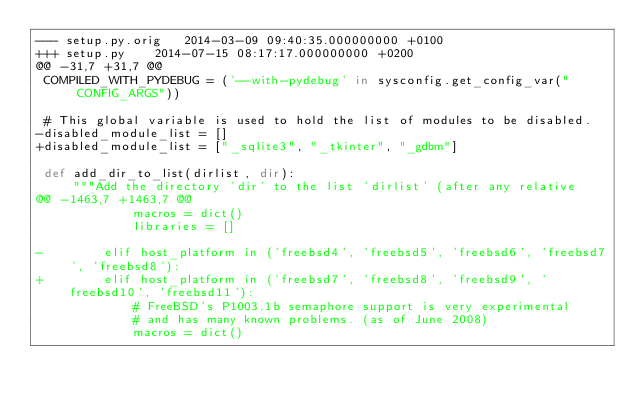<code> <loc_0><loc_0><loc_500><loc_500><_Python_>--- setup.py.orig	2014-03-09 09:40:35.000000000 +0100
+++ setup.py	2014-07-15 08:17:17.000000000 +0200
@@ -31,7 +31,7 @@
 COMPILED_WITH_PYDEBUG = ('--with-pydebug' in sysconfig.get_config_var("CONFIG_ARGS"))
 
 # This global variable is used to hold the list of modules to be disabled.
-disabled_module_list = []
+disabled_module_list = ["_sqlite3", "_tkinter", "_gdbm"]
 
 def add_dir_to_list(dirlist, dir):
     """Add the directory 'dir' to the list 'dirlist' (after any relative
@@ -1463,7 +1463,7 @@
             macros = dict()
             libraries = []
 
-        elif host_platform in ('freebsd4', 'freebsd5', 'freebsd6', 'freebsd7', 'freebsd8'):
+        elif host_platform in ('freebsd7', 'freebsd8', 'freebsd9', 'freebsd10', 'freebsd11'):
             # FreeBSD's P1003.1b semaphore support is very experimental
             # and has many known problems. (as of June 2008)
             macros = dict()
</code> 